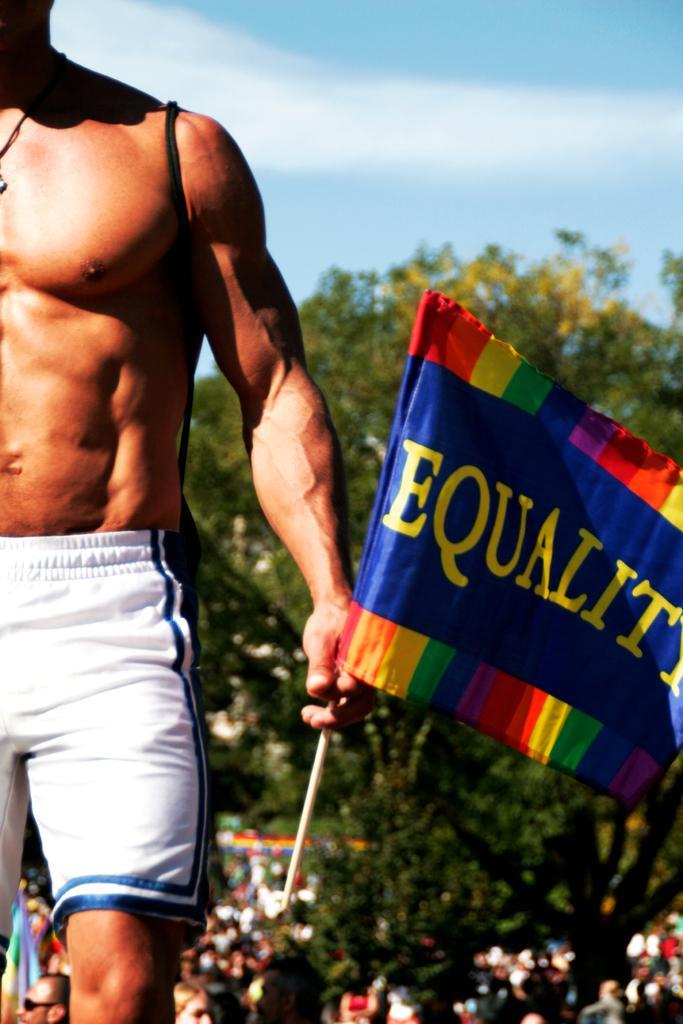How would you summarize this image in a sentence or two? In this image I can see a person wearing white and blue colored short is standing and holding a flag in his hand. In the background I can see few persons, few trees and the sky. 